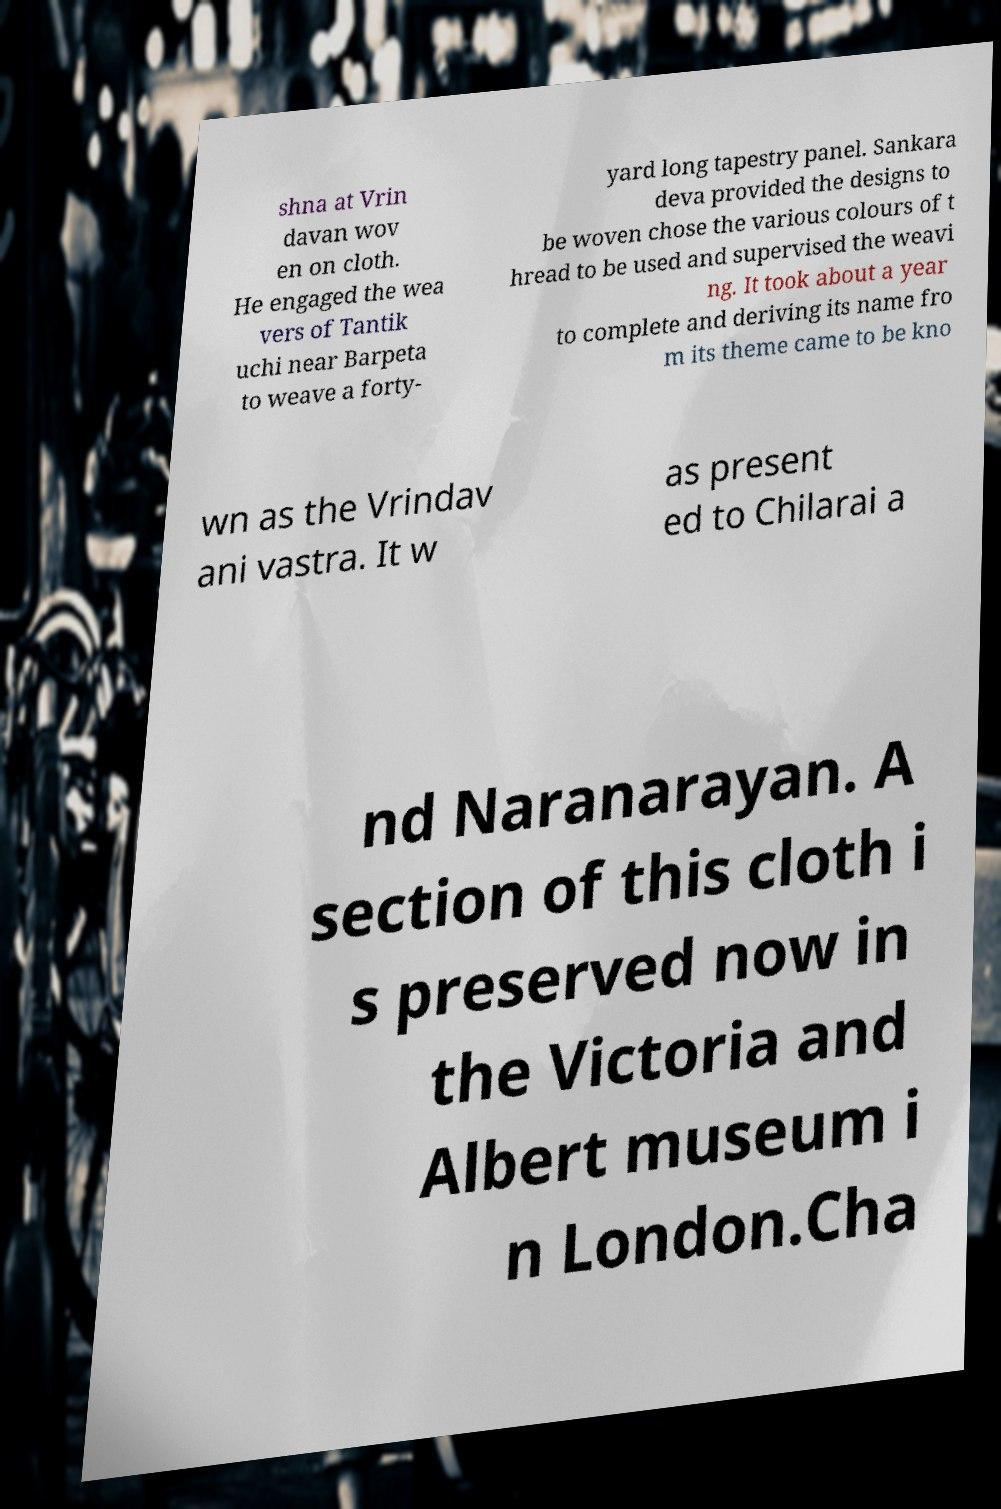There's text embedded in this image that I need extracted. Can you transcribe it verbatim? shna at Vrin davan wov en on cloth. He engaged the wea vers of Tantik uchi near Barpeta to weave a forty- yard long tapestry panel. Sankara deva provided the designs to be woven chose the various colours of t hread to be used and supervised the weavi ng. It took about a year to complete and deriving its name fro m its theme came to be kno wn as the Vrindav ani vastra. It w as present ed to Chilarai a nd Naranarayan. A section of this cloth i s preserved now in the Victoria and Albert museum i n London.Cha 